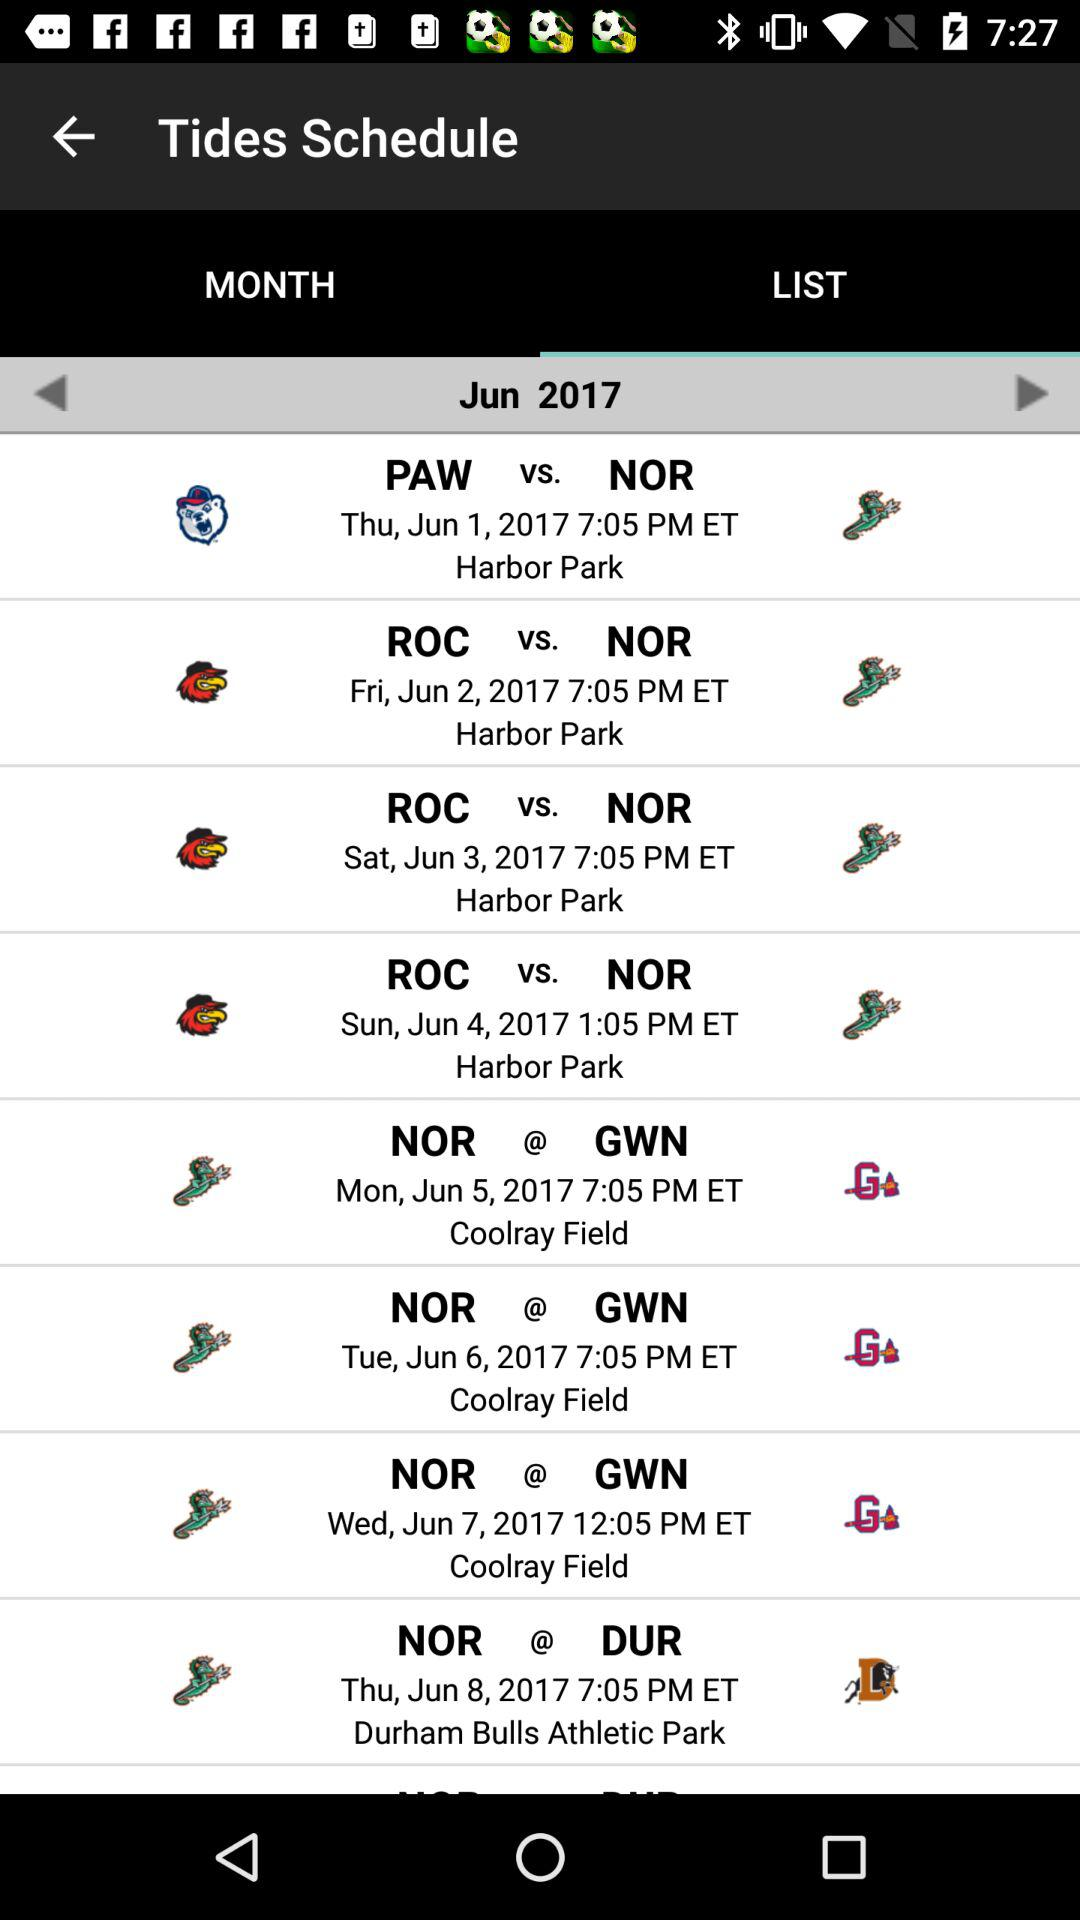At what time does the match start between NOR and GWN on June 7? The match between NOR and GWN starts at 12:05 PM ET. 